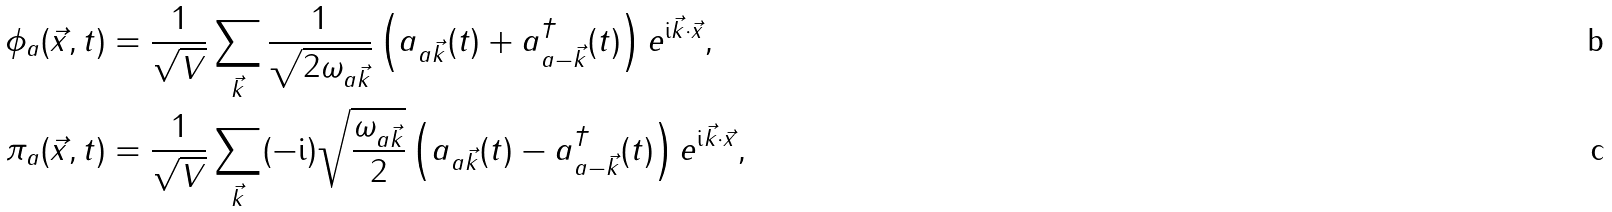<formula> <loc_0><loc_0><loc_500><loc_500>\phi _ { a } ( \vec { x } , t ) & = \frac { 1 } { \sqrt { V } } \sum _ { \vec { k } } \frac { 1 } { \sqrt { 2 \omega _ { a \vec { k } } } } \left ( a _ { a \vec { k } } ( t ) + a _ { a - \vec { k } } ^ { \dagger } ( t ) \right ) e ^ { \text  i\vec{k} \cdot \vec { x } } , \\ \pi _ { a } ( \vec { x } , t ) & = \frac { 1 } { \sqrt { V } } \sum _ { \vec { k } } ( - \text  i)\sqrt{\frac{\omega_{a\vec{k}}}{2}} \left ( a _ { a \vec { k } } ( t ) - a _ { a - \vec { k } } ^ { \dagger } ( t ) \right ) e ^ { \text  i\vec{k} \cdot \vec { x } } ,</formula> 